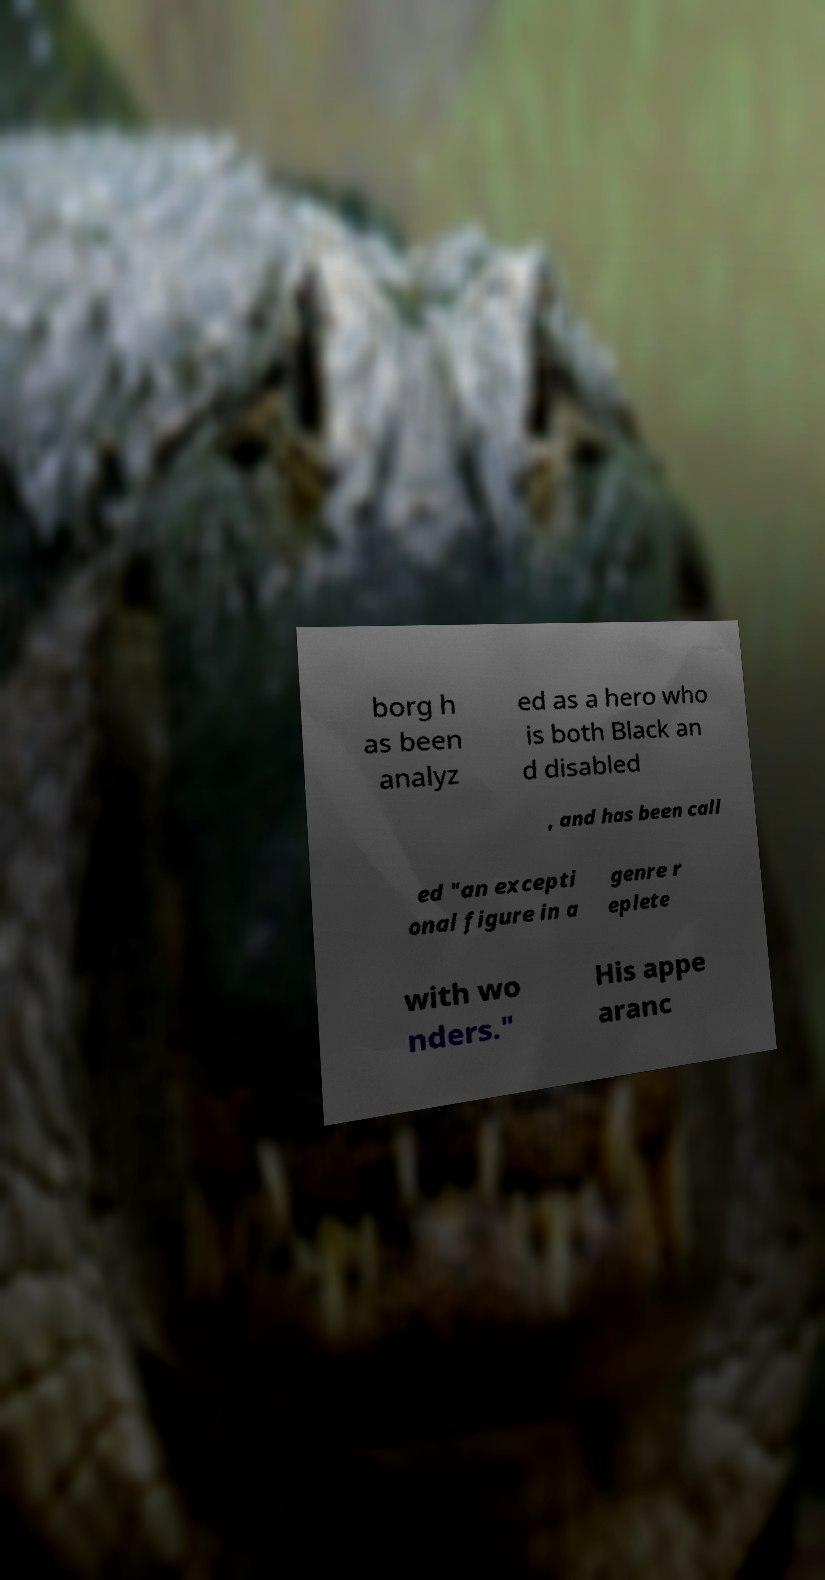Please identify and transcribe the text found in this image. borg h as been analyz ed as a hero who is both Black an d disabled , and has been call ed "an excepti onal figure in a genre r eplete with wo nders." His appe aranc 